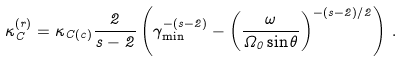<formula> <loc_0><loc_0><loc_500><loc_500>\kappa _ { C } ^ { ( r ) } = \kappa _ { C ( c ) } \frac { 2 } { s - 2 } \left ( \gamma _ { \min } ^ { - ( s - 2 ) } - \left ( \frac { \omega } { \Omega _ { 0 } \sin \theta } \right ) ^ { - ( s - 2 ) / 2 } \right ) \, .</formula> 